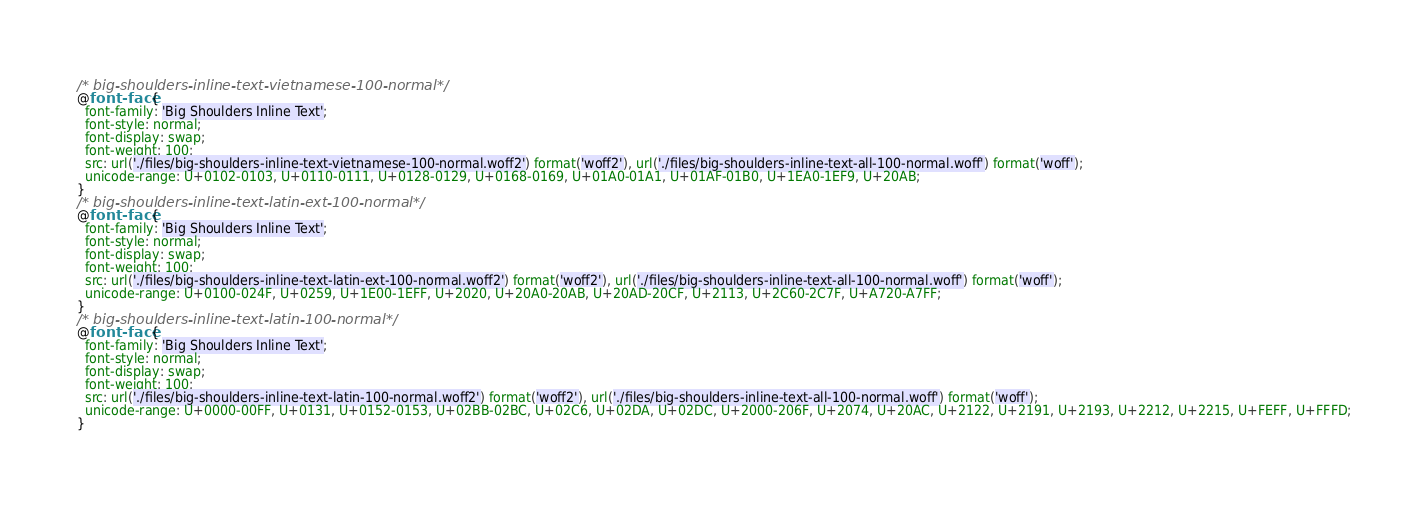Convert code to text. <code><loc_0><loc_0><loc_500><loc_500><_CSS_>/* big-shoulders-inline-text-vietnamese-100-normal*/
@font-face {
  font-family: 'Big Shoulders Inline Text';
  font-style: normal;
  font-display: swap;
  font-weight: 100;
  src: url('./files/big-shoulders-inline-text-vietnamese-100-normal.woff2') format('woff2'), url('./files/big-shoulders-inline-text-all-100-normal.woff') format('woff');
  unicode-range: U+0102-0103, U+0110-0111, U+0128-0129, U+0168-0169, U+01A0-01A1, U+01AF-01B0, U+1EA0-1EF9, U+20AB;
}
/* big-shoulders-inline-text-latin-ext-100-normal*/
@font-face {
  font-family: 'Big Shoulders Inline Text';
  font-style: normal;
  font-display: swap;
  font-weight: 100;
  src: url('./files/big-shoulders-inline-text-latin-ext-100-normal.woff2') format('woff2'), url('./files/big-shoulders-inline-text-all-100-normal.woff') format('woff');
  unicode-range: U+0100-024F, U+0259, U+1E00-1EFF, U+2020, U+20A0-20AB, U+20AD-20CF, U+2113, U+2C60-2C7F, U+A720-A7FF;
}
/* big-shoulders-inline-text-latin-100-normal*/
@font-face {
  font-family: 'Big Shoulders Inline Text';
  font-style: normal;
  font-display: swap;
  font-weight: 100;
  src: url('./files/big-shoulders-inline-text-latin-100-normal.woff2') format('woff2'), url('./files/big-shoulders-inline-text-all-100-normal.woff') format('woff');
  unicode-range: U+0000-00FF, U+0131, U+0152-0153, U+02BB-02BC, U+02C6, U+02DA, U+02DC, U+2000-206F, U+2074, U+20AC, U+2122, U+2191, U+2193, U+2212, U+2215, U+FEFF, U+FFFD;
}
</code> 